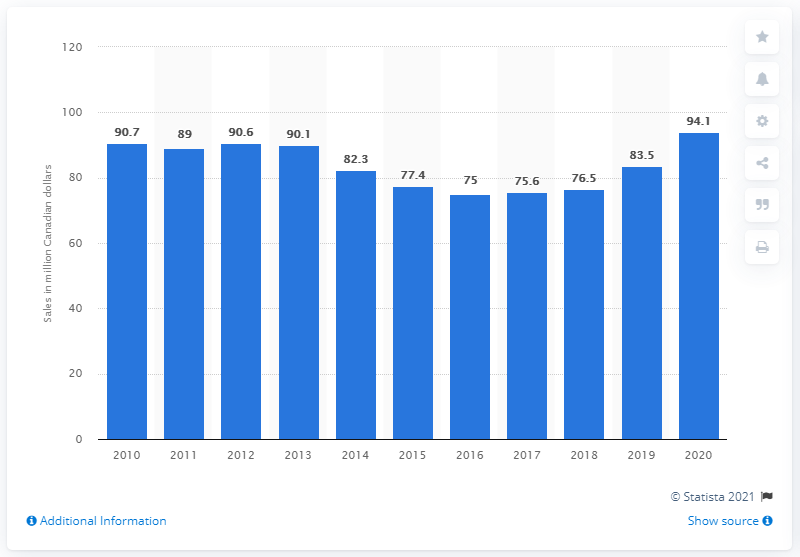Point out several critical features in this image. In the Canadian province of Quebec in 2020, the sales of beer totaled 94.1 million liters. The previous year's sales of beer in Quebec were 83.5 million dollars. 